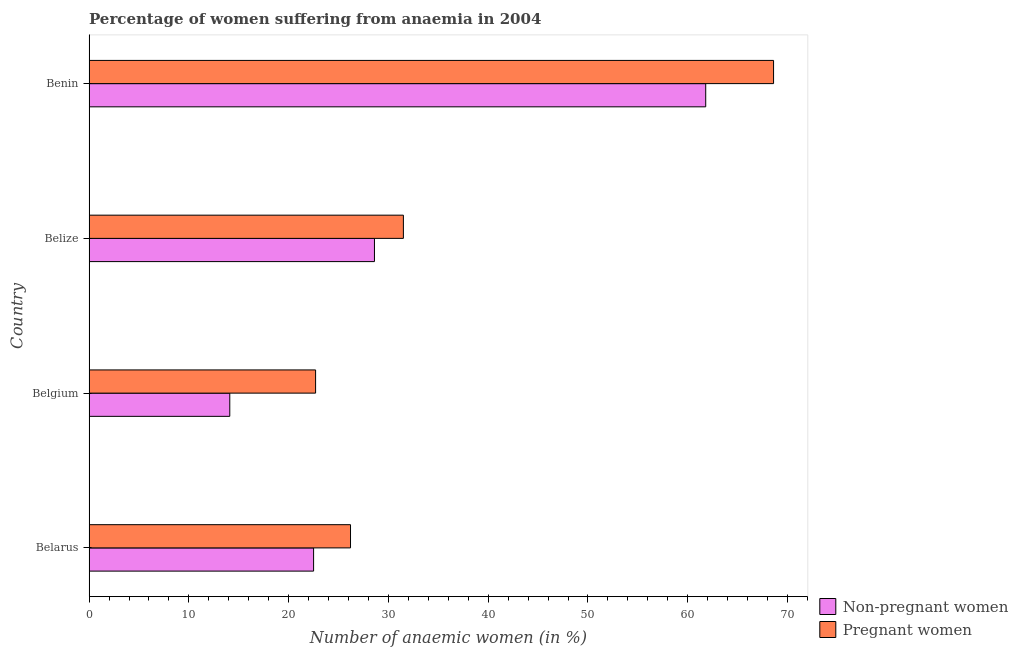How many different coloured bars are there?
Ensure brevity in your answer.  2. Are the number of bars per tick equal to the number of legend labels?
Provide a succinct answer. Yes. Are the number of bars on each tick of the Y-axis equal?
Your answer should be very brief. Yes. How many bars are there on the 3rd tick from the bottom?
Your response must be concise. 2. What is the label of the 1st group of bars from the top?
Ensure brevity in your answer.  Benin. In how many cases, is the number of bars for a given country not equal to the number of legend labels?
Your answer should be very brief. 0. What is the percentage of pregnant anaemic women in Belarus?
Provide a succinct answer. 26.2. Across all countries, what is the maximum percentage of pregnant anaemic women?
Provide a short and direct response. 68.6. Across all countries, what is the minimum percentage of pregnant anaemic women?
Keep it short and to the point. 22.7. In which country was the percentage of non-pregnant anaemic women maximum?
Your answer should be compact. Benin. What is the total percentage of non-pregnant anaemic women in the graph?
Provide a succinct answer. 127. What is the difference between the percentage of pregnant anaemic women in Belize and that in Benin?
Offer a very short reply. -37.1. What is the difference between the percentage of non-pregnant anaemic women in Belgium and the percentage of pregnant anaemic women in Belize?
Your response must be concise. -17.4. What is the average percentage of non-pregnant anaemic women per country?
Offer a terse response. 31.75. What is the ratio of the percentage of non-pregnant anaemic women in Belize to that in Benin?
Your response must be concise. 0.46. Is the percentage of pregnant anaemic women in Belgium less than that in Belize?
Offer a very short reply. Yes. Is the difference between the percentage of pregnant anaemic women in Belgium and Benin greater than the difference between the percentage of non-pregnant anaemic women in Belgium and Benin?
Offer a terse response. Yes. What is the difference between the highest and the second highest percentage of pregnant anaemic women?
Make the answer very short. 37.1. What is the difference between the highest and the lowest percentage of pregnant anaemic women?
Provide a short and direct response. 45.9. In how many countries, is the percentage of non-pregnant anaemic women greater than the average percentage of non-pregnant anaemic women taken over all countries?
Keep it short and to the point. 1. Is the sum of the percentage of non-pregnant anaemic women in Belarus and Belgium greater than the maximum percentage of pregnant anaemic women across all countries?
Provide a short and direct response. No. What does the 1st bar from the top in Benin represents?
Keep it short and to the point. Pregnant women. What does the 2nd bar from the bottom in Belarus represents?
Your response must be concise. Pregnant women. How many bars are there?
Offer a very short reply. 8. Are all the bars in the graph horizontal?
Provide a short and direct response. Yes. What is the difference between two consecutive major ticks on the X-axis?
Provide a short and direct response. 10. Are the values on the major ticks of X-axis written in scientific E-notation?
Keep it short and to the point. No. Where does the legend appear in the graph?
Your answer should be very brief. Bottom right. How are the legend labels stacked?
Your response must be concise. Vertical. What is the title of the graph?
Your answer should be compact. Percentage of women suffering from anaemia in 2004. What is the label or title of the X-axis?
Offer a terse response. Number of anaemic women (in %). What is the Number of anaemic women (in %) in Non-pregnant women in Belarus?
Make the answer very short. 22.5. What is the Number of anaemic women (in %) in Pregnant women in Belarus?
Provide a short and direct response. 26.2. What is the Number of anaemic women (in %) of Pregnant women in Belgium?
Make the answer very short. 22.7. What is the Number of anaemic women (in %) in Non-pregnant women in Belize?
Offer a terse response. 28.6. What is the Number of anaemic women (in %) in Pregnant women in Belize?
Your answer should be compact. 31.5. What is the Number of anaemic women (in %) of Non-pregnant women in Benin?
Ensure brevity in your answer.  61.8. What is the Number of anaemic women (in %) of Pregnant women in Benin?
Your answer should be very brief. 68.6. Across all countries, what is the maximum Number of anaemic women (in %) in Non-pregnant women?
Your response must be concise. 61.8. Across all countries, what is the maximum Number of anaemic women (in %) in Pregnant women?
Offer a very short reply. 68.6. Across all countries, what is the minimum Number of anaemic women (in %) of Pregnant women?
Keep it short and to the point. 22.7. What is the total Number of anaemic women (in %) of Non-pregnant women in the graph?
Keep it short and to the point. 127. What is the total Number of anaemic women (in %) of Pregnant women in the graph?
Your answer should be compact. 149. What is the difference between the Number of anaemic women (in %) of Non-pregnant women in Belarus and that in Belize?
Your response must be concise. -6.1. What is the difference between the Number of anaemic women (in %) of Non-pregnant women in Belarus and that in Benin?
Your answer should be very brief. -39.3. What is the difference between the Number of anaemic women (in %) in Pregnant women in Belarus and that in Benin?
Offer a very short reply. -42.4. What is the difference between the Number of anaemic women (in %) of Non-pregnant women in Belgium and that in Belize?
Offer a very short reply. -14.5. What is the difference between the Number of anaemic women (in %) of Non-pregnant women in Belgium and that in Benin?
Ensure brevity in your answer.  -47.7. What is the difference between the Number of anaemic women (in %) in Pregnant women in Belgium and that in Benin?
Provide a short and direct response. -45.9. What is the difference between the Number of anaemic women (in %) of Non-pregnant women in Belize and that in Benin?
Make the answer very short. -33.2. What is the difference between the Number of anaemic women (in %) of Pregnant women in Belize and that in Benin?
Your response must be concise. -37.1. What is the difference between the Number of anaemic women (in %) of Non-pregnant women in Belarus and the Number of anaemic women (in %) of Pregnant women in Belize?
Provide a succinct answer. -9. What is the difference between the Number of anaemic women (in %) in Non-pregnant women in Belarus and the Number of anaemic women (in %) in Pregnant women in Benin?
Your response must be concise. -46.1. What is the difference between the Number of anaemic women (in %) in Non-pregnant women in Belgium and the Number of anaemic women (in %) in Pregnant women in Belize?
Your response must be concise. -17.4. What is the difference between the Number of anaemic women (in %) of Non-pregnant women in Belgium and the Number of anaemic women (in %) of Pregnant women in Benin?
Offer a very short reply. -54.5. What is the average Number of anaemic women (in %) in Non-pregnant women per country?
Offer a terse response. 31.75. What is the average Number of anaemic women (in %) in Pregnant women per country?
Make the answer very short. 37.25. What is the difference between the Number of anaemic women (in %) in Non-pregnant women and Number of anaemic women (in %) in Pregnant women in Belgium?
Offer a terse response. -8.6. What is the difference between the Number of anaemic women (in %) of Non-pregnant women and Number of anaemic women (in %) of Pregnant women in Benin?
Offer a very short reply. -6.8. What is the ratio of the Number of anaemic women (in %) in Non-pregnant women in Belarus to that in Belgium?
Make the answer very short. 1.6. What is the ratio of the Number of anaemic women (in %) of Pregnant women in Belarus to that in Belgium?
Keep it short and to the point. 1.15. What is the ratio of the Number of anaemic women (in %) in Non-pregnant women in Belarus to that in Belize?
Provide a short and direct response. 0.79. What is the ratio of the Number of anaemic women (in %) in Pregnant women in Belarus to that in Belize?
Offer a very short reply. 0.83. What is the ratio of the Number of anaemic women (in %) in Non-pregnant women in Belarus to that in Benin?
Provide a short and direct response. 0.36. What is the ratio of the Number of anaemic women (in %) in Pregnant women in Belarus to that in Benin?
Provide a short and direct response. 0.38. What is the ratio of the Number of anaemic women (in %) in Non-pregnant women in Belgium to that in Belize?
Offer a very short reply. 0.49. What is the ratio of the Number of anaemic women (in %) in Pregnant women in Belgium to that in Belize?
Provide a succinct answer. 0.72. What is the ratio of the Number of anaemic women (in %) of Non-pregnant women in Belgium to that in Benin?
Offer a very short reply. 0.23. What is the ratio of the Number of anaemic women (in %) in Pregnant women in Belgium to that in Benin?
Give a very brief answer. 0.33. What is the ratio of the Number of anaemic women (in %) in Non-pregnant women in Belize to that in Benin?
Make the answer very short. 0.46. What is the ratio of the Number of anaemic women (in %) of Pregnant women in Belize to that in Benin?
Provide a succinct answer. 0.46. What is the difference between the highest and the second highest Number of anaemic women (in %) in Non-pregnant women?
Your answer should be compact. 33.2. What is the difference between the highest and the second highest Number of anaemic women (in %) in Pregnant women?
Keep it short and to the point. 37.1. What is the difference between the highest and the lowest Number of anaemic women (in %) of Non-pregnant women?
Your answer should be very brief. 47.7. What is the difference between the highest and the lowest Number of anaemic women (in %) in Pregnant women?
Offer a terse response. 45.9. 